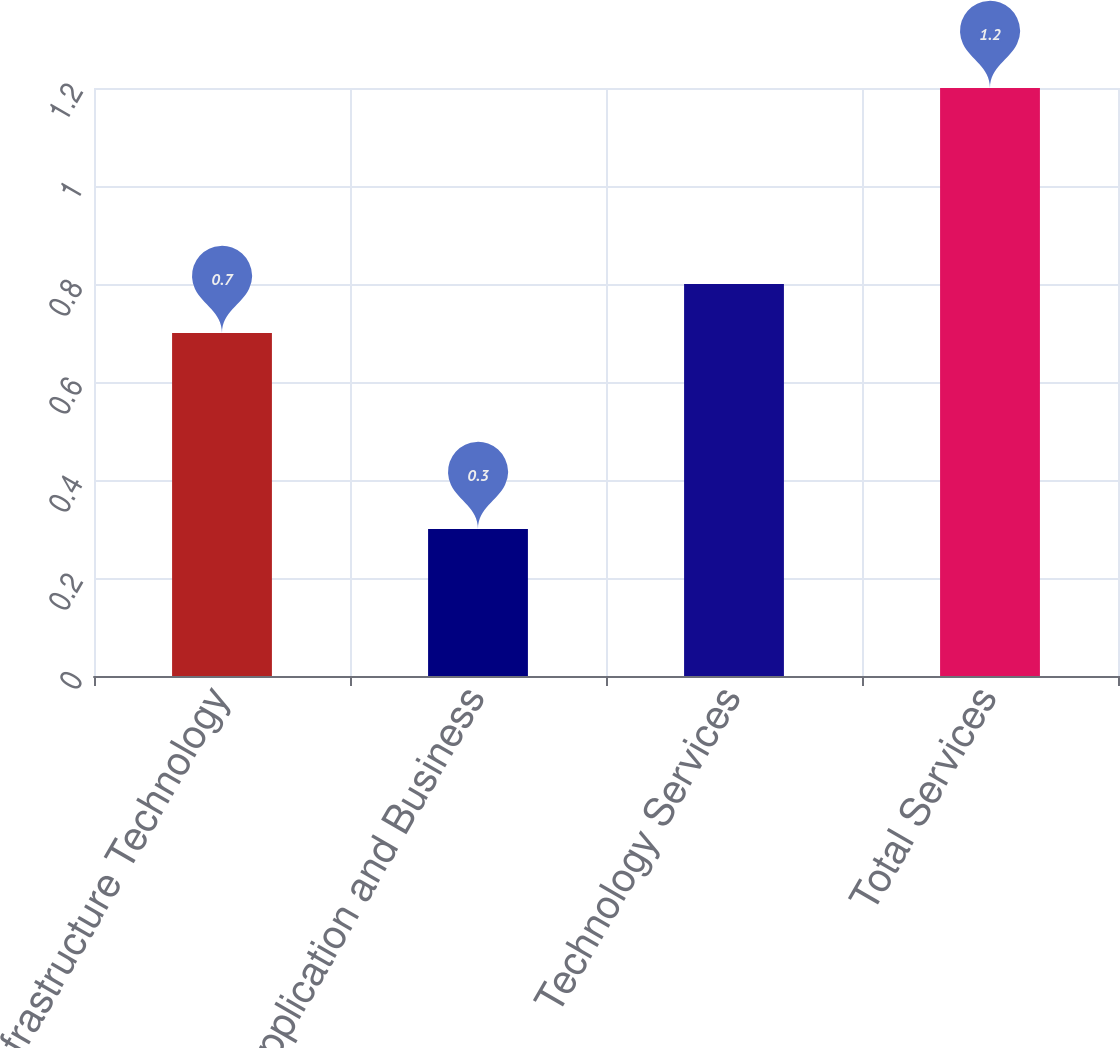Convert chart. <chart><loc_0><loc_0><loc_500><loc_500><bar_chart><fcel>Infrastructure Technology<fcel>Application and Business<fcel>Technology Services<fcel>Total Services<nl><fcel>0.7<fcel>0.3<fcel>0.8<fcel>1.2<nl></chart> 